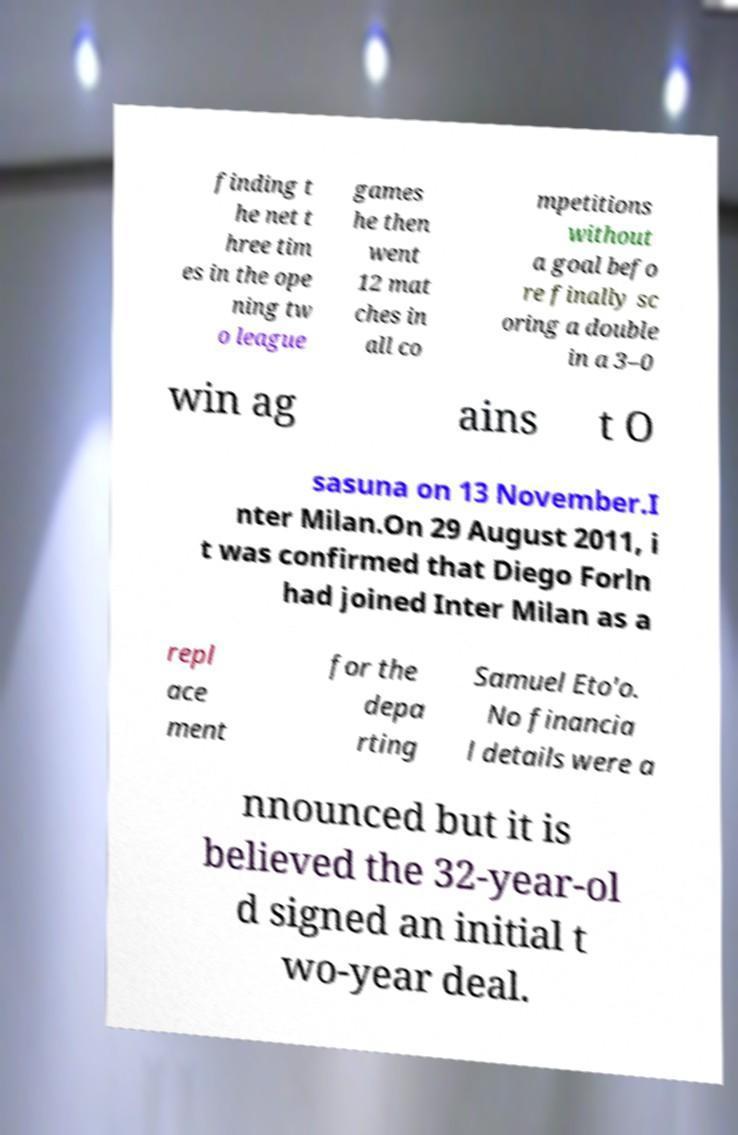I need the written content from this picture converted into text. Can you do that? finding t he net t hree tim es in the ope ning tw o league games he then went 12 mat ches in all co mpetitions without a goal befo re finally sc oring a double in a 3–0 win ag ains t O sasuna on 13 November.I nter Milan.On 29 August 2011, i t was confirmed that Diego Forln had joined Inter Milan as a repl ace ment for the depa rting Samuel Eto'o. No financia l details were a nnounced but it is believed the 32-year-ol d signed an initial t wo-year deal. 